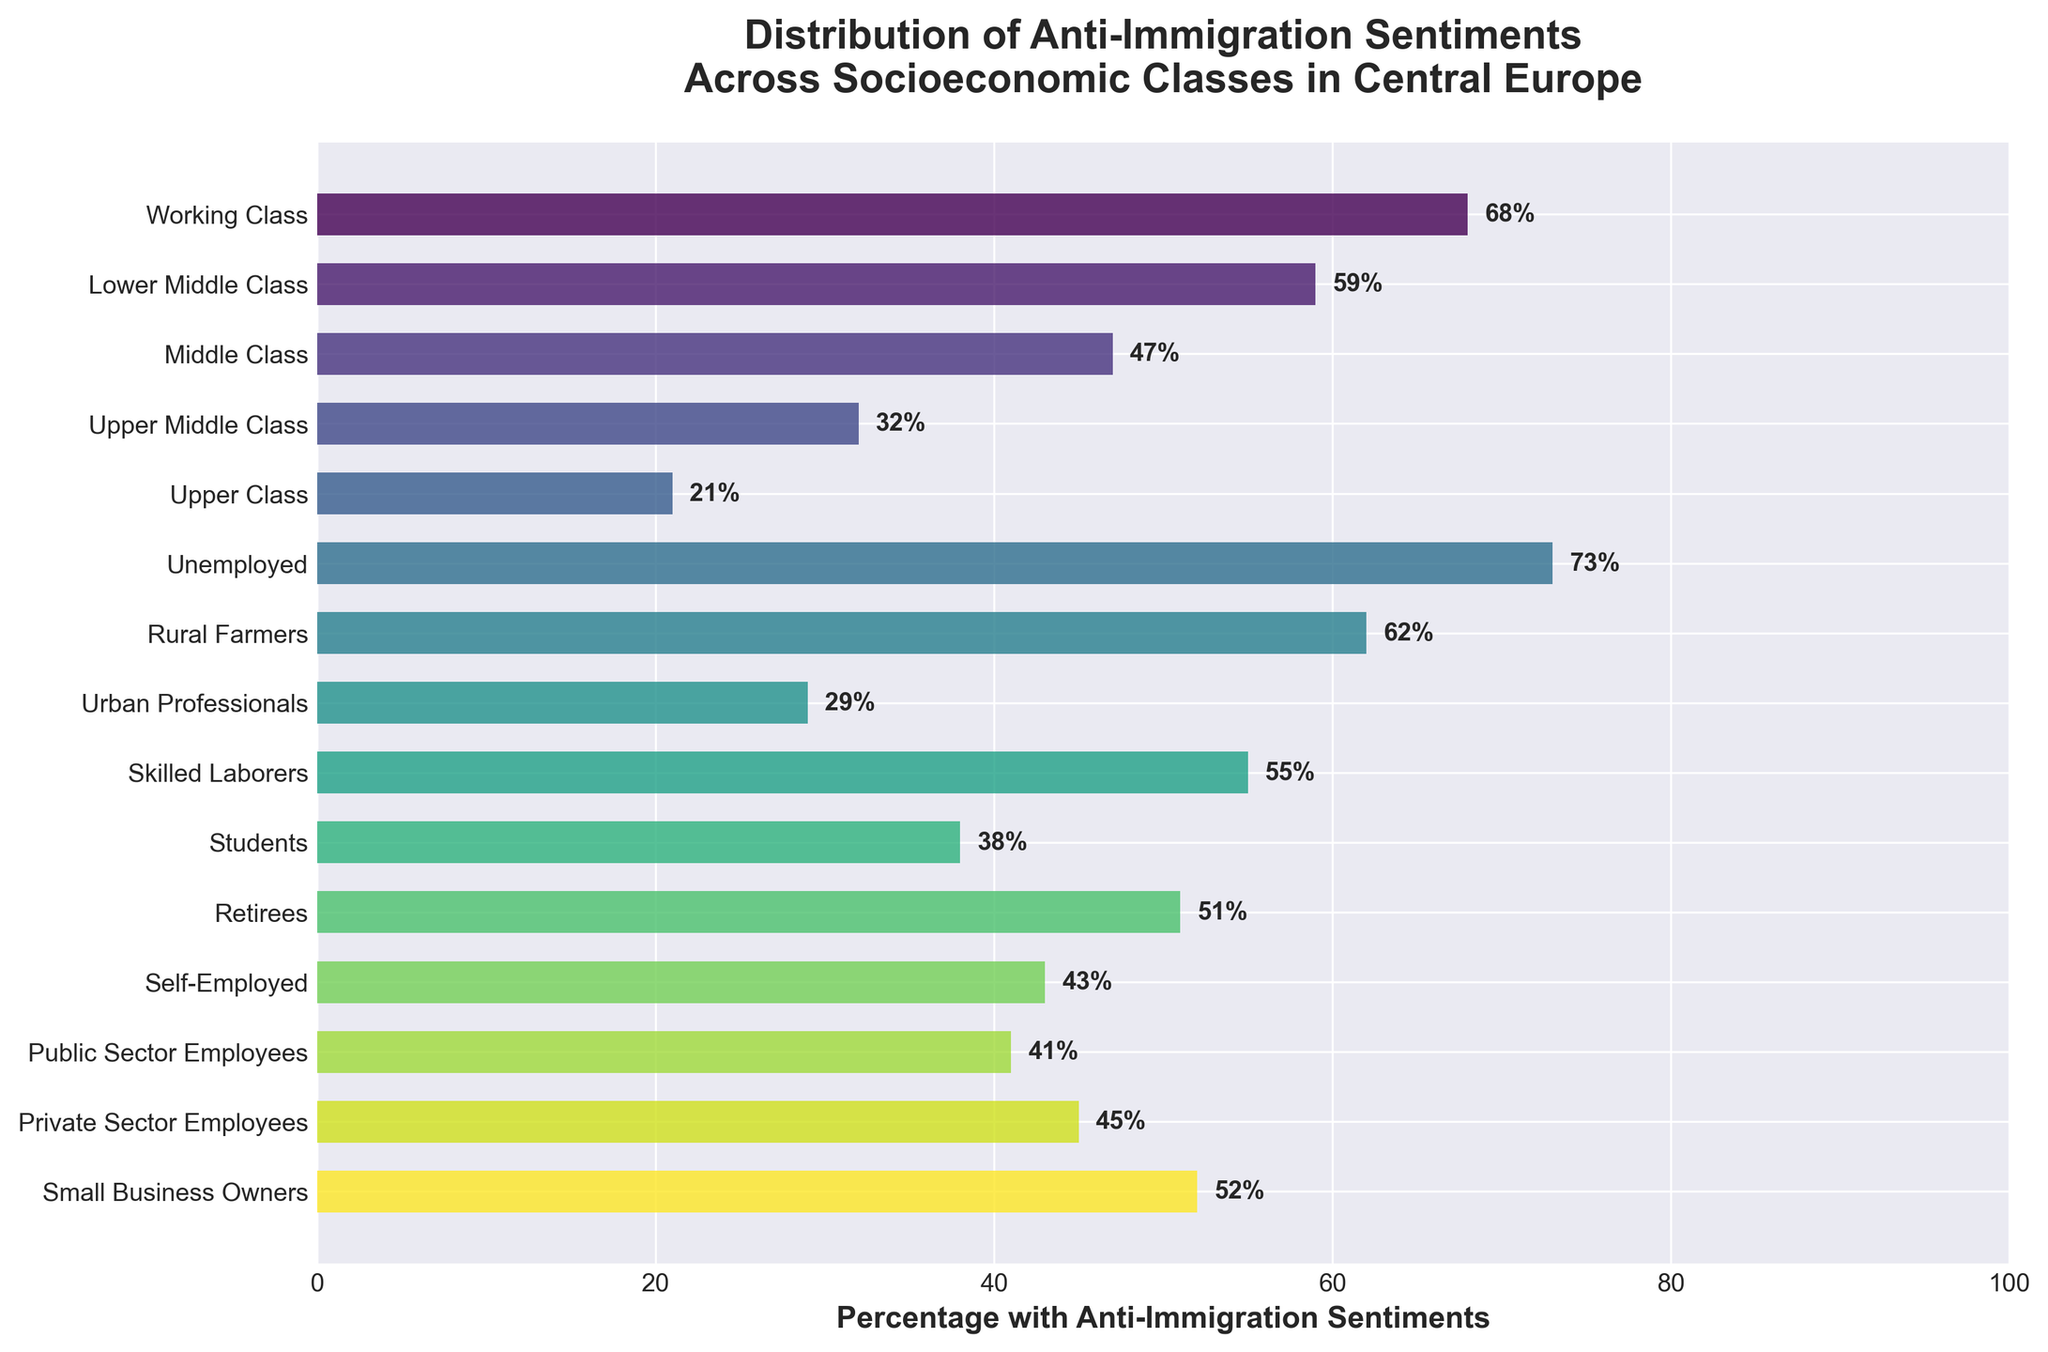Which socioeconomic class has the highest percentage with anti-immigration sentiments? The bar chart shows the percentage data for each socioeconomic class. The "Unemployed" group has the highest percentage.
Answer: Unemployed Which two classes have the closest percentages of anti-immigration sentiments? By comparing the bars visually, "Retirees" (51%) and "Small Business Owners" (52%) have very close percentages.
Answer: Retirees and Small Business Owners What is the average percentage of anti-immigration sentiments for "Middle Class," "Upper Middle Class," "Urban Professionals," and "Public Sector Employees"? Calculate the average by summing the percentages of these classes (47 + 32 + 29 + 41) and divide by the number of classes: (47 + 32 + 29 + 41) / 4 = 37.25
Answer: 37.25 Which socioeconomic class has the lowest percentage with anti-immigration sentiments, and what is that percentage? The bar representing "Upper Class" is the shortest, indicating this class has the lowest percentage, which is 21%.
Answer: Upper Class, 21% What is the difference in the percentage of anti-immigration sentiments between "Working Class" and "Students"? Subtract the percentage for "Students" from the percentage for "Working Class": 68 - 38 = 30.
Answer: 30 List all socioeconomic classes that have a percentage of anti-immigration sentiments higher than 50%. Identify the classes visually and list them: Working Class (68%), Lower Middle Class (59%), Unemployed (73%), Rural Farmers (62%), Skilled Laborers (55%), Retirees (51%), Small Business Owners (52%).
Answer: Working Class, Lower Middle Class, Unemployed, Rural Farmers, Skilled Laborers, Retirees, Small Business Owners How much higher is the percentage of anti-immigration sentiments in "Skilled Laborers" compared to "Self-Employed"? Subtract the percentage for "Self-Employed" from the percentage for "Skilled Laborers": 55 - 43 = 12.
Answer: 12 Which class has the largest difference in anti-immigration sentiments compared to the "Middle Class"? By comparing the differences visually, the "Unemployed" class has the largest difference: 73 - 47 = 26.
Answer: Unemployed What is the median percentage of anti-immigration sentiments for all socioeconomic classes? Order the percentages and find the middle value(s). There are 15 values, the 8th value is the median: Ordered: 21, 29, 32, 38, 41, 43, 45, 47, 51, 52, 55, 59, 62, 68, 73. The middle (8th) value is 47.
Answer: 47 